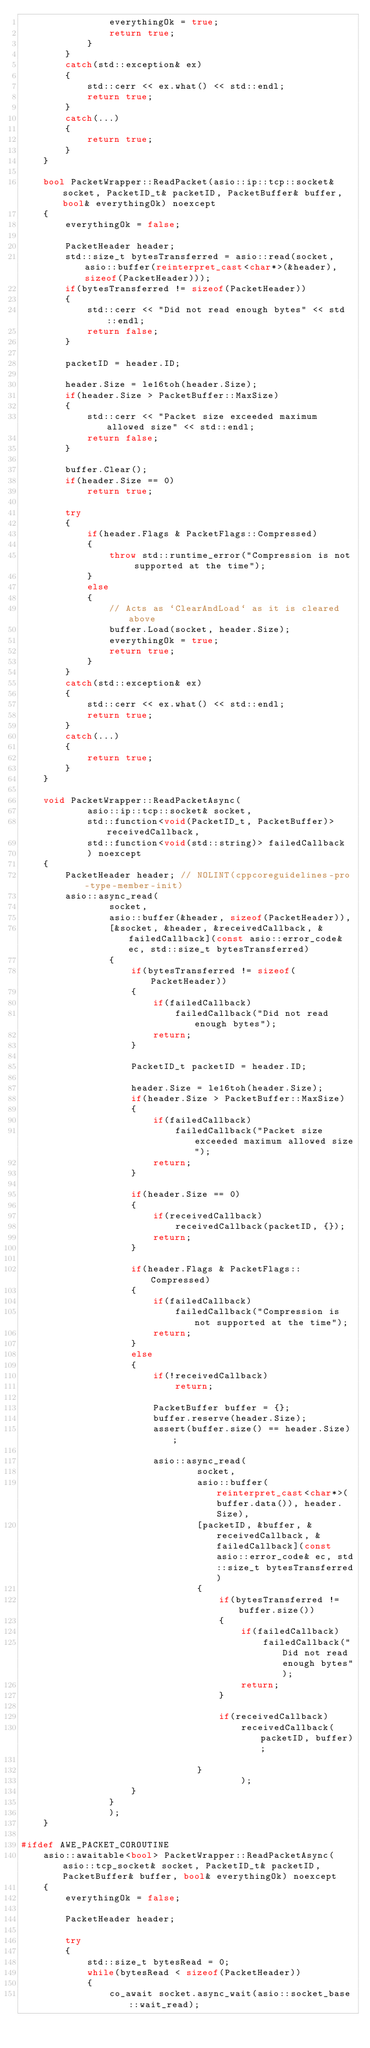<code> <loc_0><loc_0><loc_500><loc_500><_C++_>                everythingOk = true;
                return true;
            }
        }
        catch(std::exception& ex)
        {
            std::cerr << ex.what() << std::endl;
            return true;
        }
        catch(...)
        {
            return true;
        }
    }

    bool PacketWrapper::ReadPacket(asio::ip::tcp::socket& socket, PacketID_t& packetID, PacketBuffer& buffer, bool& everythingOk) noexcept
    {
        everythingOk = false;

        PacketHeader header;
        std::size_t bytesTransferred = asio::read(socket, asio::buffer(reinterpret_cast<char*>(&header), sizeof(PacketHeader)));
        if(bytesTransferred != sizeof(PacketHeader))
        {
            std::cerr << "Did not read enough bytes" << std::endl;
            return false;
        }

        packetID = header.ID;

        header.Size = le16toh(header.Size);
        if(header.Size > PacketBuffer::MaxSize)
        {
            std::cerr << "Packet size exceeded maximum allowed size" << std::endl;
            return false;
        }

        buffer.Clear();
        if(header.Size == 0)
            return true;

        try
        {
            if(header.Flags & PacketFlags::Compressed)
            {
                throw std::runtime_error("Compression is not supported at the time");
            }
            else
            {
                // Acts as `ClearAndLoad` as it is cleared above
                buffer.Load(socket, header.Size);
                everythingOk = true;
                return true;
            }
        }
        catch(std::exception& ex)
        {
            std::cerr << ex.what() << std::endl;
            return true;
        }
        catch(...)
        {
            return true;
        }
    }

    void PacketWrapper::ReadPacketAsync(
            asio::ip::tcp::socket& socket,
            std::function<void(PacketID_t, PacketBuffer)> receivedCallback,
            std::function<void(std::string)> failedCallback
            ) noexcept
    {
        PacketHeader header; // NOLINT(cppcoreguidelines-pro-type-member-init)
        asio::async_read(
                socket,
                asio::buffer(&header, sizeof(PacketHeader)),
                [&socket, &header, &receivedCallback, &failedCallback](const asio::error_code& ec, std::size_t bytesTransferred)
                {
                    if(bytesTransferred != sizeof(PacketHeader))
                    {
                        if(failedCallback)
                            failedCallback("Did not read enough bytes");
                        return;
                    }

                    PacketID_t packetID = header.ID;

                    header.Size = le16toh(header.Size);
                    if(header.Size > PacketBuffer::MaxSize)
                    {
                        if(failedCallback)
                            failedCallback("Packet size exceeded maximum allowed size");
                        return;
                    }

                    if(header.Size == 0)
                    {
                        if(receivedCallback)
                            receivedCallback(packetID, {});
                        return;
                    }

                    if(header.Flags & PacketFlags::Compressed)
                    {
                        if(failedCallback)
                            failedCallback("Compression is not supported at the time");
                        return;
                    }
                    else
                    {
                        if(!receivedCallback)
                            return;

                        PacketBuffer buffer = {};
                        buffer.reserve(header.Size);
                        assert(buffer.size() == header.Size);

                        asio::async_read(
                                socket,
                                asio::buffer(reinterpret_cast<char*>(buffer.data()), header.Size),
                                [packetID, &buffer, &receivedCallback, &failedCallback](const asio::error_code& ec, std::size_t bytesTransferred)
                                {
                                    if(bytesTransferred != buffer.size())
                                    {
                                        if(failedCallback)
                                            failedCallback("Did not read enough bytes");
                                        return;
                                    }

                                    if(receivedCallback)
                                        receivedCallback(packetID, buffer);

                                }
                                        );
                    }
                }
                );
    }

#ifdef AWE_PACKET_COROUTINE
    asio::awaitable<bool> PacketWrapper::ReadPacketAsync(asio::tcp_socket& socket, PacketID_t& packetID, PacketBuffer& buffer, bool& everythingOk) noexcept
    {
        everythingOk = false;

        PacketHeader header;

        try
        {
            std::size_t bytesRead = 0;
            while(bytesRead < sizeof(PacketHeader))
            {
                co_await socket.async_wait(asio::socket_base::wait_read);</code> 